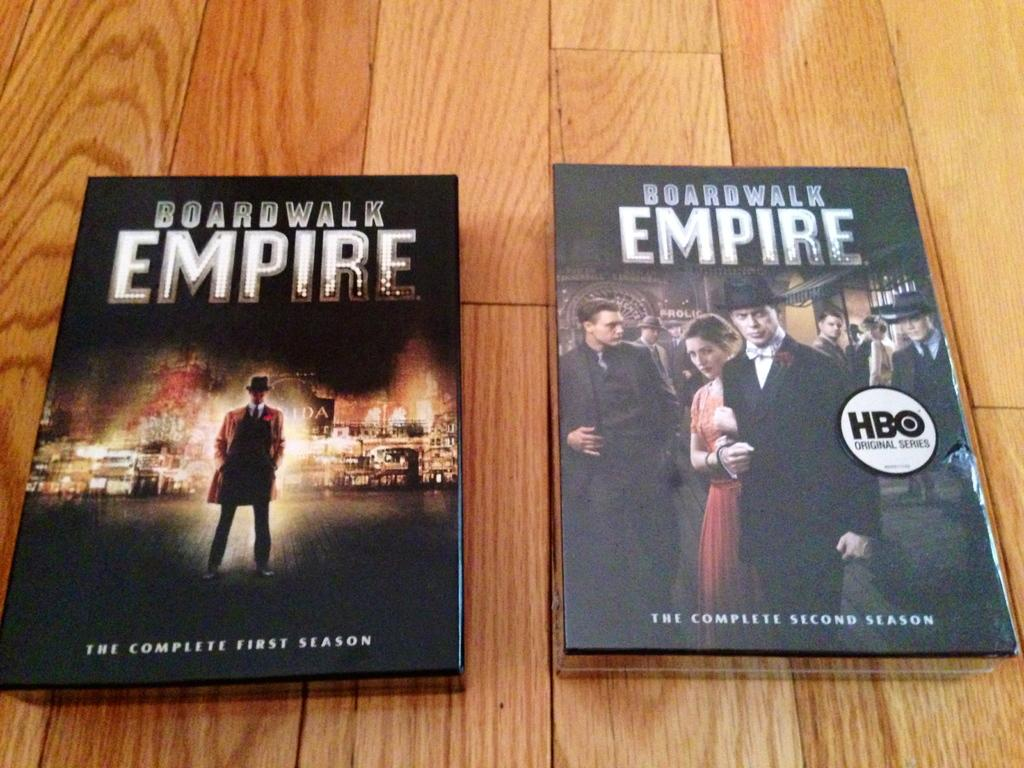<image>
Present a compact description of the photo's key features. The first and second seasons of Boardwalk Empire. 